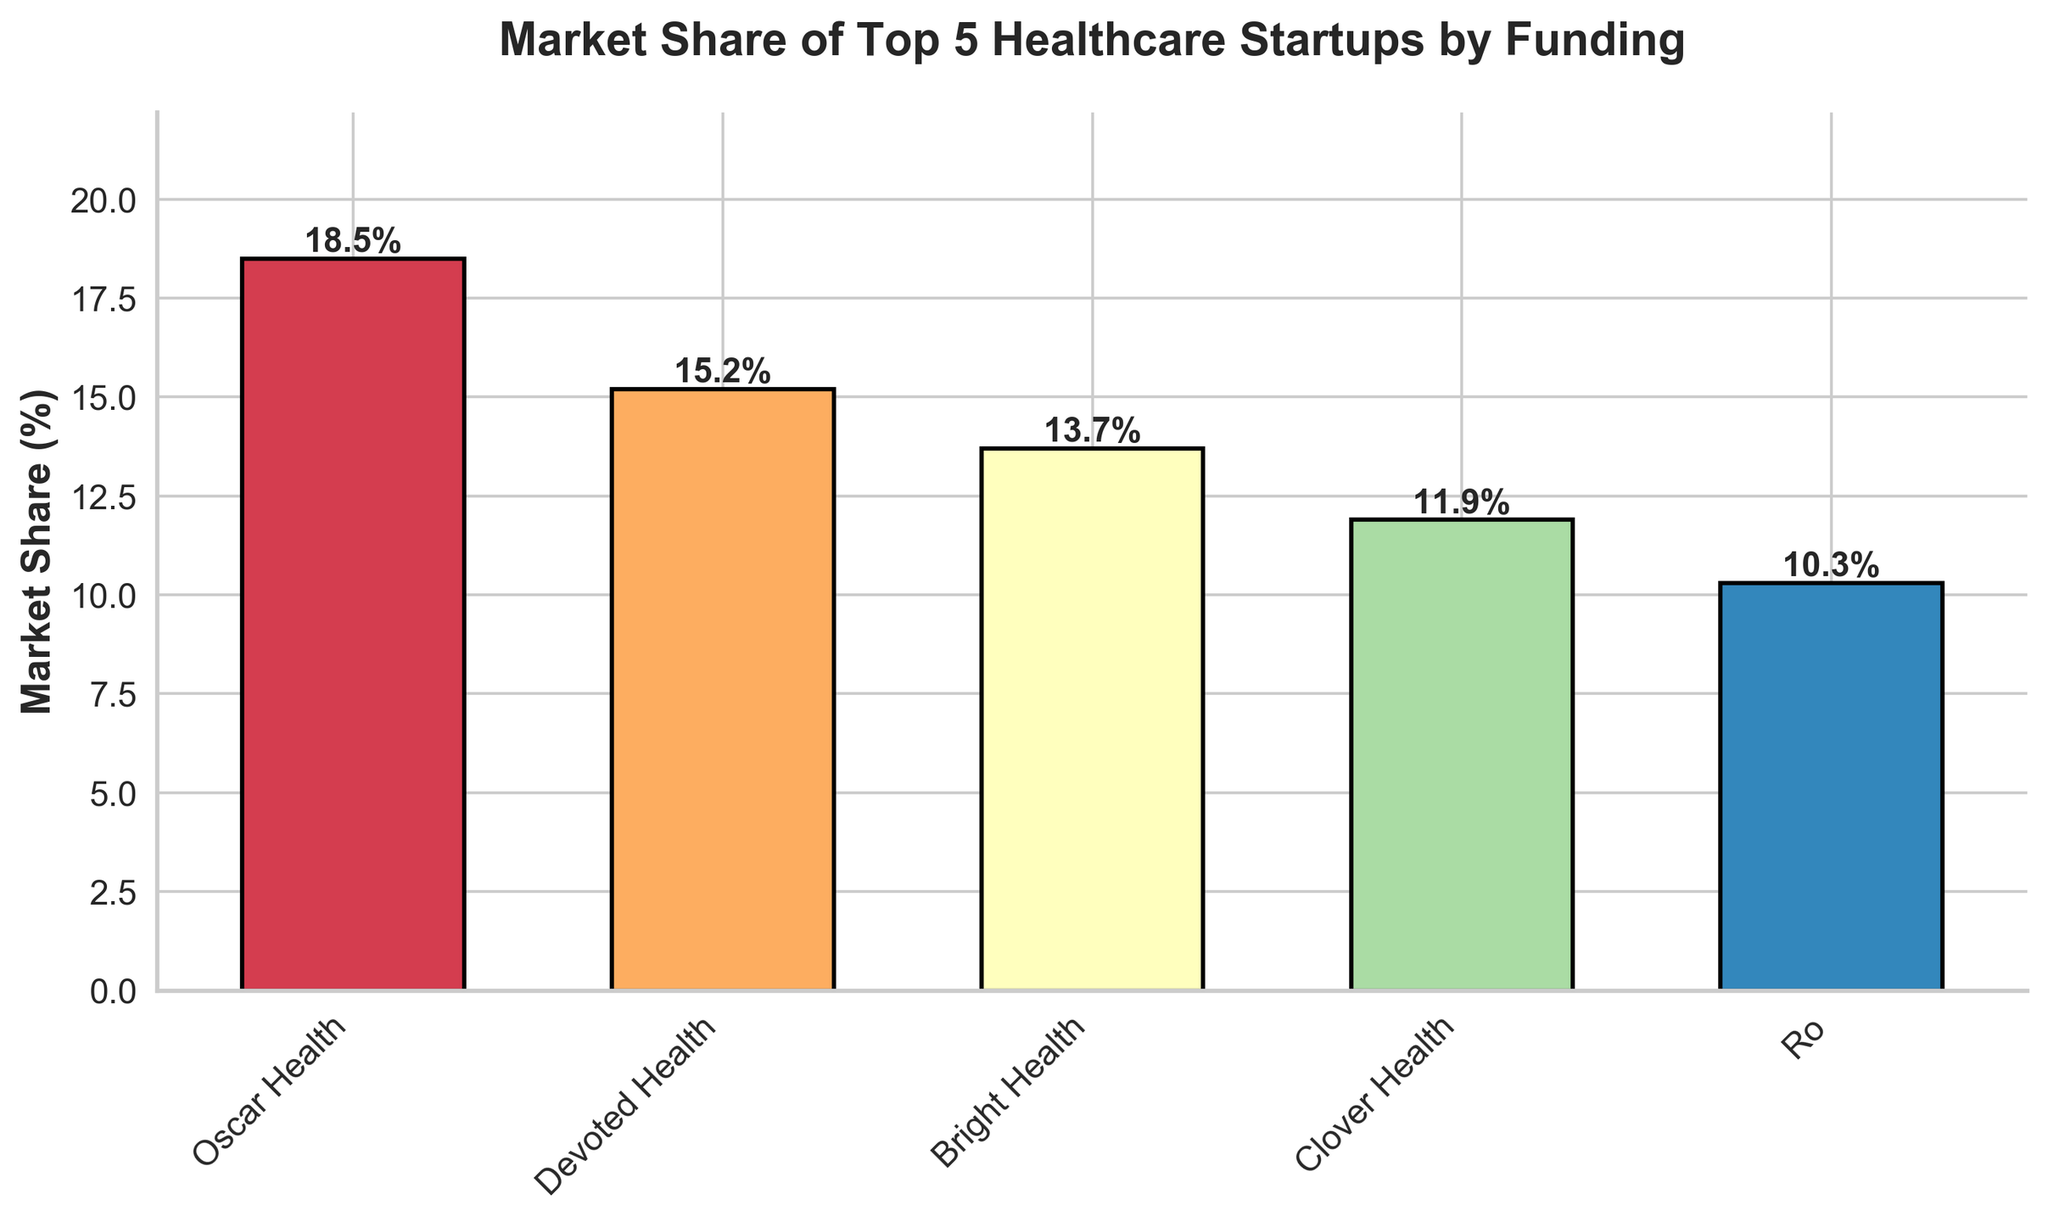What is the market share of the company with the lowest funding among the top 5 healthcare startups? Look for the company that has the shortest bar. In this case, Ro has the shortest bar, indicating it has the lowest market share of 10.3%.
Answer: 10.3% Which company has the largest market share? Identify the company with the tallest bar. Oscar Health has the tallest bar with a market share of 18.5%.
Answer: Oscar Health How much higher is the market share of Oscar Health compared to Bright Health? Subtract Bright Health's market share from Oscar Health's market share: 18.5% - 13.7% = 4.8%
Answer: 4.8% What is the combined market share of Devoted Health and Clover Health? Add their market shares: Devoted Health (15.2%) + Clover Health (11.9%) = 27.1%
Answer: 27.1% Which two companies have the closest market share values? Compare the differences in market shares for all pairs. The closest difference is between Bright Health (13.7%) and Clover Health (11.9%), which is 1.8%.
Answer: Bright Health and Clover Health What is the average market share of the top 5 healthcare startups? Add all the market shares and divide by 5: (18.5% + 15.2% + 13.7% + 11.9% + 10.3%) / 5 = 13.92%
Answer: 13.92% Is the combined market share of Ro and Clover Health greater than the market share of Oscar Health? Compare the sum of Ro (10.3%) and Clover Health (11.9%) with Oscar Health (18.5%): 10.3% + 11.9% = 22.2%, which is greater than 18.5%.
Answer: Yes If the market shares were sorted in ascending order, which company would be in the middle? Arrange the market shares in ascending order: Ro (10.3%), Clover Health (11.9%), Bright Health (13.7%), Devoted Health (15.2%), Oscar Health (18.5%). The middle company is Bright Health.
Answer: Bright Health 